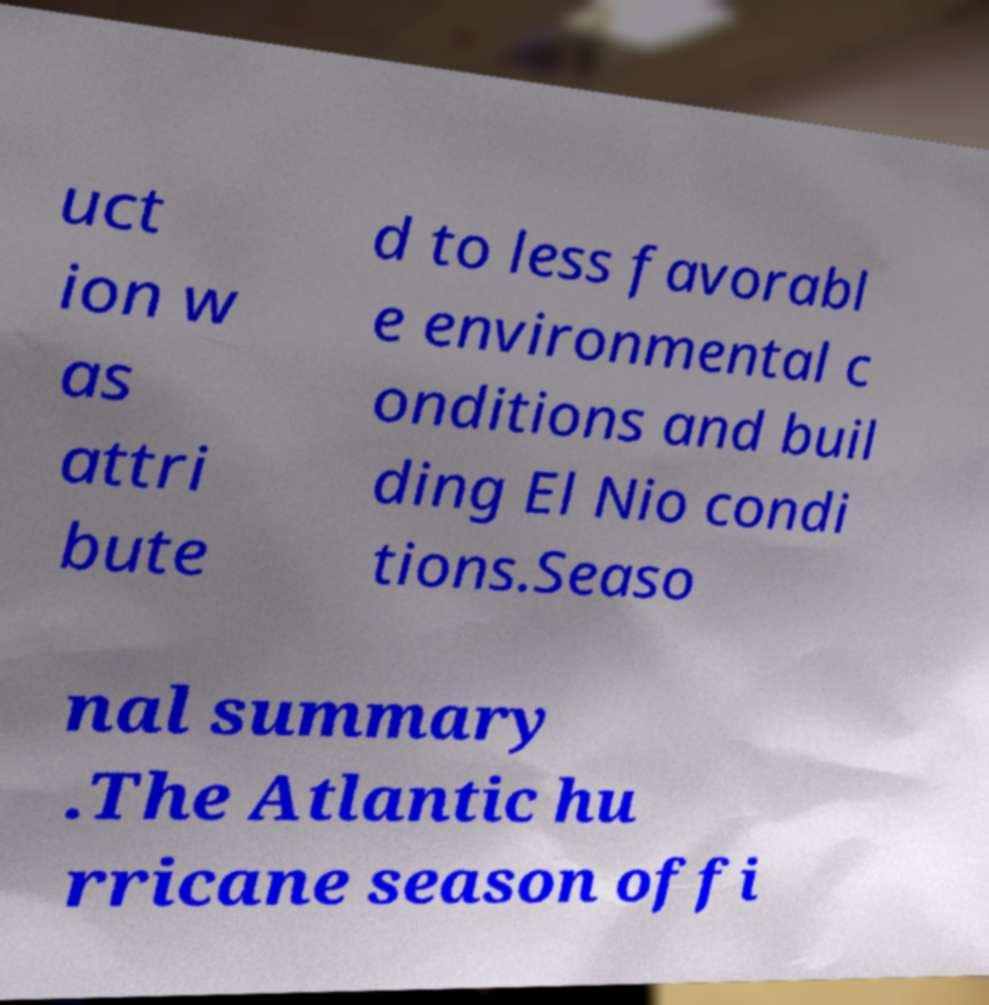Could you extract and type out the text from this image? uct ion w as attri bute d to less favorabl e environmental c onditions and buil ding El Nio condi tions.Seaso nal summary .The Atlantic hu rricane season offi 